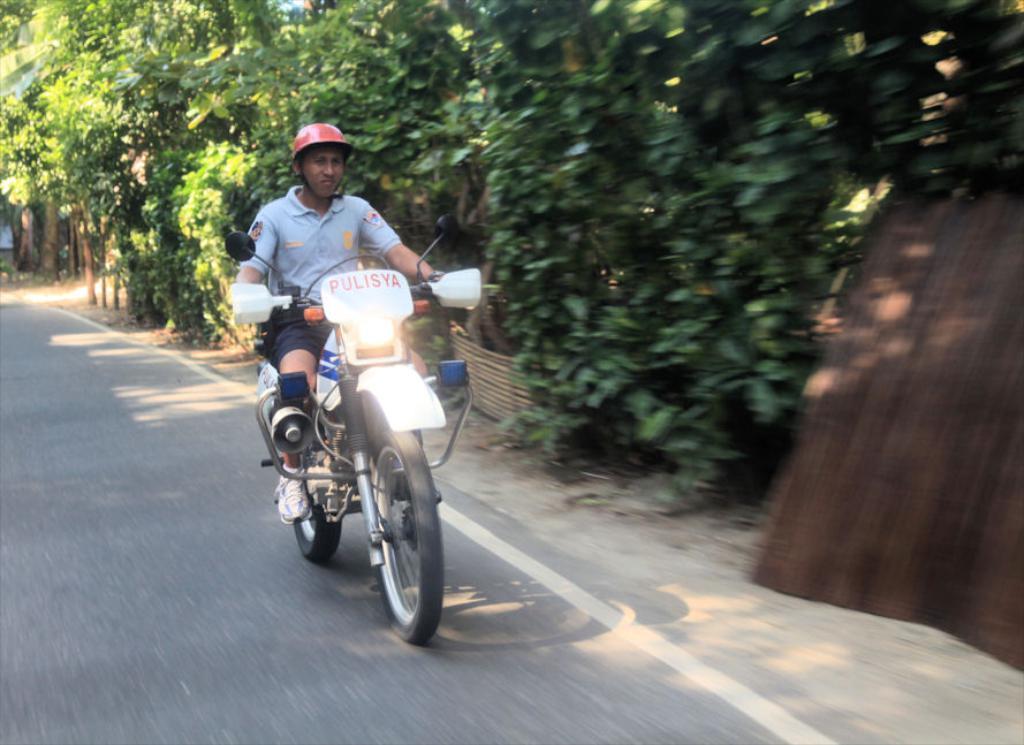In one or two sentences, can you explain what this image depicts? In this image a man is riding a motorcycle. He is wearing a red helmet. In the background there are trees. 